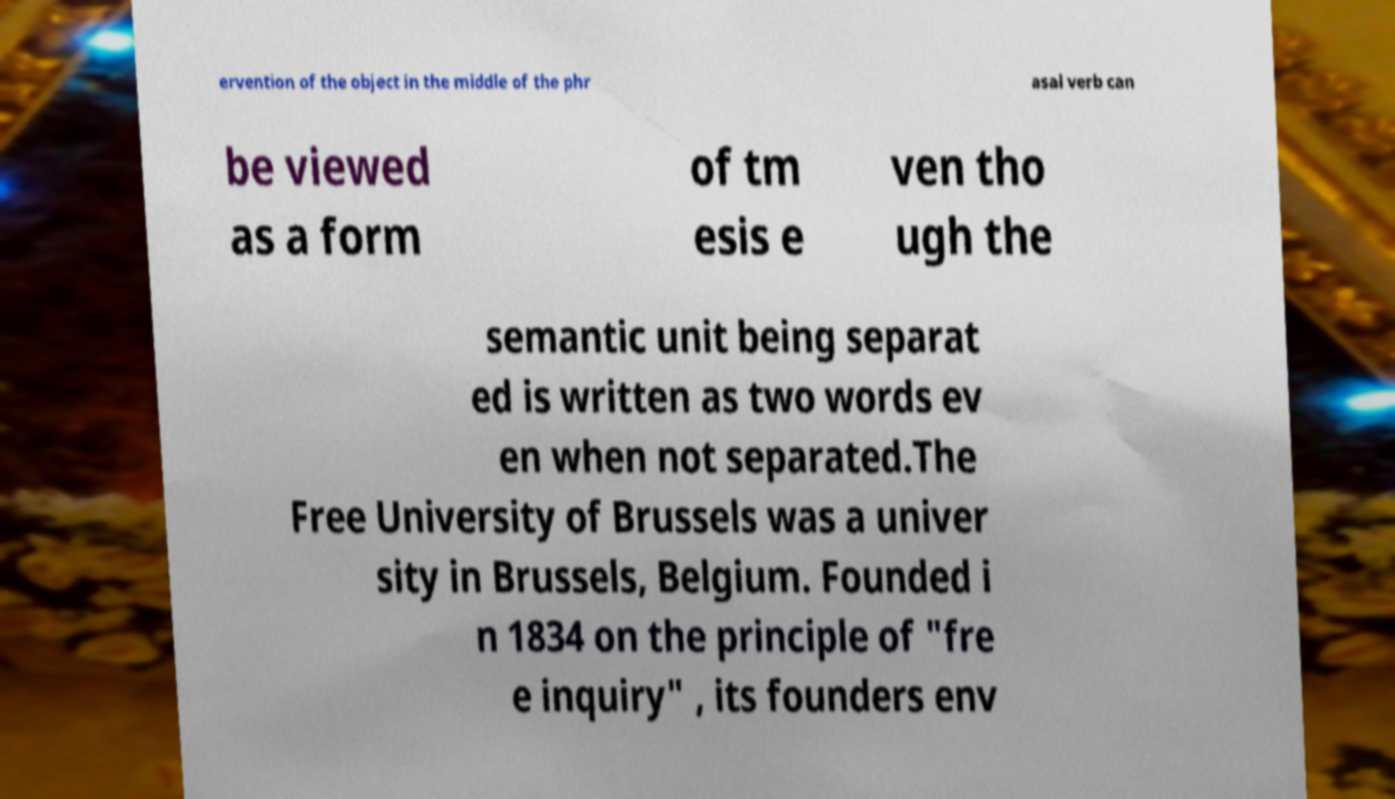I need the written content from this picture converted into text. Can you do that? ervention of the object in the middle of the phr asal verb can be viewed as a form of tm esis e ven tho ugh the semantic unit being separat ed is written as two words ev en when not separated.The Free University of Brussels was a univer sity in Brussels, Belgium. Founded i n 1834 on the principle of "fre e inquiry" , its founders env 